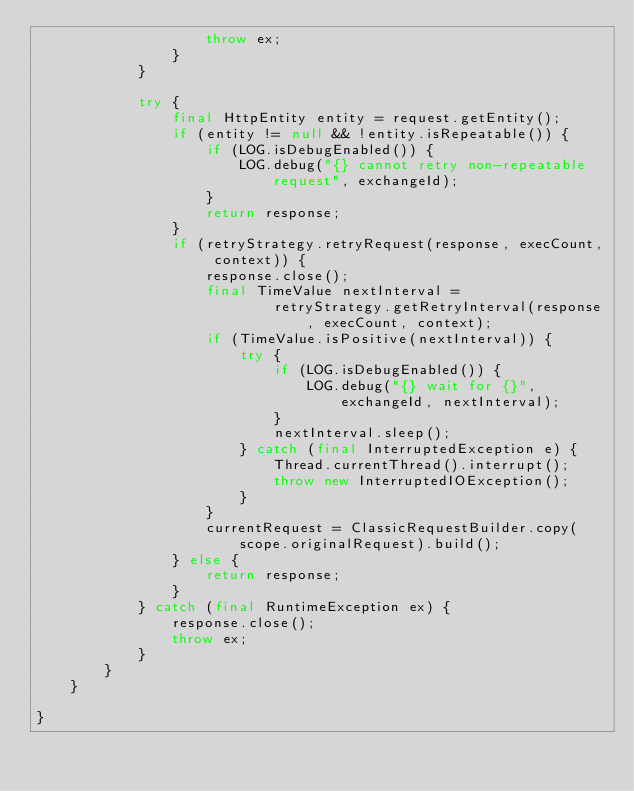Convert code to text. <code><loc_0><loc_0><loc_500><loc_500><_Java_>                    throw ex;
                }
            }

            try {
                final HttpEntity entity = request.getEntity();
                if (entity != null && !entity.isRepeatable()) {
                    if (LOG.isDebugEnabled()) {
                        LOG.debug("{} cannot retry non-repeatable request", exchangeId);
                    }
                    return response;
                }
                if (retryStrategy.retryRequest(response, execCount, context)) {
                    response.close();
                    final TimeValue nextInterval =
                            retryStrategy.getRetryInterval(response, execCount, context);
                    if (TimeValue.isPositive(nextInterval)) {
                        try {
                            if (LOG.isDebugEnabled()) {
                                LOG.debug("{} wait for {}", exchangeId, nextInterval);
                            }
                            nextInterval.sleep();
                        } catch (final InterruptedException e) {
                            Thread.currentThread().interrupt();
                            throw new InterruptedIOException();
                        }
                    }
                    currentRequest = ClassicRequestBuilder.copy(scope.originalRequest).build();
                } else {
                    return response;
                }
            } catch (final RuntimeException ex) {
                response.close();
                throw ex;
            }
        }
    }

}
</code> 